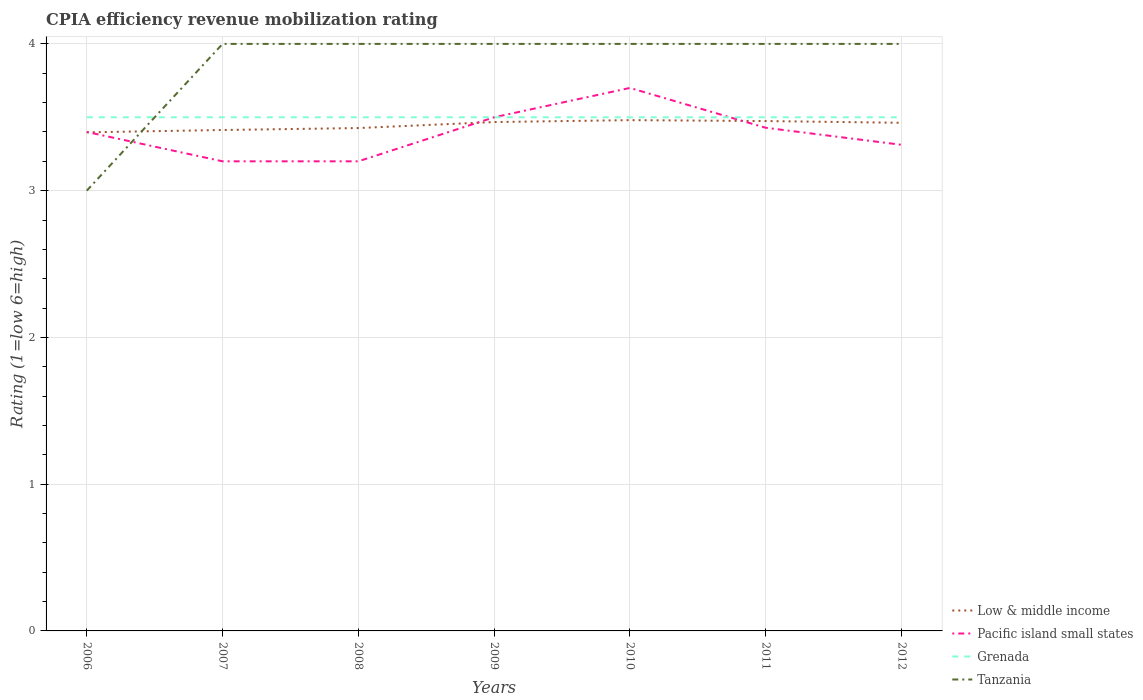Is the number of lines equal to the number of legend labels?
Offer a very short reply. Yes. Across all years, what is the maximum CPIA rating in Low & middle income?
Your response must be concise. 3.4. In which year was the CPIA rating in Tanzania maximum?
Your answer should be very brief. 2006. Is the CPIA rating in Grenada strictly greater than the CPIA rating in Tanzania over the years?
Give a very brief answer. No. How many lines are there?
Make the answer very short. 4. How many years are there in the graph?
Your answer should be very brief. 7. What is the difference between two consecutive major ticks on the Y-axis?
Your answer should be very brief. 1. Does the graph contain any zero values?
Give a very brief answer. No. How many legend labels are there?
Ensure brevity in your answer.  4. What is the title of the graph?
Make the answer very short. CPIA efficiency revenue mobilization rating. Does "Sierra Leone" appear as one of the legend labels in the graph?
Give a very brief answer. No. What is the Rating (1=low 6=high) in Low & middle income in 2006?
Keep it short and to the point. 3.4. What is the Rating (1=low 6=high) in Tanzania in 2006?
Your response must be concise. 3. What is the Rating (1=low 6=high) in Low & middle income in 2007?
Provide a short and direct response. 3.41. What is the Rating (1=low 6=high) of Grenada in 2007?
Offer a very short reply. 3.5. What is the Rating (1=low 6=high) of Low & middle income in 2008?
Your response must be concise. 3.43. What is the Rating (1=low 6=high) in Pacific island small states in 2008?
Provide a succinct answer. 3.2. What is the Rating (1=low 6=high) of Grenada in 2008?
Offer a terse response. 3.5. What is the Rating (1=low 6=high) in Low & middle income in 2009?
Provide a succinct answer. 3.47. What is the Rating (1=low 6=high) of Pacific island small states in 2009?
Make the answer very short. 3.5. What is the Rating (1=low 6=high) in Grenada in 2009?
Give a very brief answer. 3.5. What is the Rating (1=low 6=high) of Tanzania in 2009?
Your response must be concise. 4. What is the Rating (1=low 6=high) of Low & middle income in 2010?
Your response must be concise. 3.48. What is the Rating (1=low 6=high) of Tanzania in 2010?
Provide a succinct answer. 4. What is the Rating (1=low 6=high) of Low & middle income in 2011?
Your answer should be compact. 3.47. What is the Rating (1=low 6=high) in Pacific island small states in 2011?
Your answer should be very brief. 3.43. What is the Rating (1=low 6=high) in Low & middle income in 2012?
Your response must be concise. 3.46. What is the Rating (1=low 6=high) in Pacific island small states in 2012?
Make the answer very short. 3.31. What is the Rating (1=low 6=high) of Grenada in 2012?
Provide a short and direct response. 3.5. What is the Rating (1=low 6=high) of Tanzania in 2012?
Offer a very short reply. 4. Across all years, what is the maximum Rating (1=low 6=high) of Low & middle income?
Your answer should be compact. 3.48. Across all years, what is the maximum Rating (1=low 6=high) of Pacific island small states?
Your response must be concise. 3.7. Across all years, what is the maximum Rating (1=low 6=high) in Grenada?
Give a very brief answer. 3.5. Across all years, what is the minimum Rating (1=low 6=high) of Low & middle income?
Your answer should be very brief. 3.4. Across all years, what is the minimum Rating (1=low 6=high) of Grenada?
Provide a short and direct response. 3.5. What is the total Rating (1=low 6=high) in Low & middle income in the graph?
Your answer should be very brief. 24.12. What is the total Rating (1=low 6=high) of Pacific island small states in the graph?
Make the answer very short. 23.74. What is the total Rating (1=low 6=high) in Tanzania in the graph?
Keep it short and to the point. 27. What is the difference between the Rating (1=low 6=high) in Low & middle income in 2006 and that in 2007?
Ensure brevity in your answer.  -0.02. What is the difference between the Rating (1=low 6=high) of Pacific island small states in 2006 and that in 2007?
Give a very brief answer. 0.2. What is the difference between the Rating (1=low 6=high) of Grenada in 2006 and that in 2007?
Provide a succinct answer. 0. What is the difference between the Rating (1=low 6=high) in Tanzania in 2006 and that in 2007?
Offer a terse response. -1. What is the difference between the Rating (1=low 6=high) of Low & middle income in 2006 and that in 2008?
Give a very brief answer. -0.03. What is the difference between the Rating (1=low 6=high) of Pacific island small states in 2006 and that in 2008?
Make the answer very short. 0.2. What is the difference between the Rating (1=low 6=high) of Low & middle income in 2006 and that in 2009?
Offer a very short reply. -0.07. What is the difference between the Rating (1=low 6=high) of Pacific island small states in 2006 and that in 2009?
Your answer should be very brief. -0.1. What is the difference between the Rating (1=low 6=high) of Low & middle income in 2006 and that in 2010?
Your response must be concise. -0.08. What is the difference between the Rating (1=low 6=high) of Low & middle income in 2006 and that in 2011?
Provide a succinct answer. -0.08. What is the difference between the Rating (1=low 6=high) of Pacific island small states in 2006 and that in 2011?
Keep it short and to the point. -0.03. What is the difference between the Rating (1=low 6=high) of Tanzania in 2006 and that in 2011?
Give a very brief answer. -1. What is the difference between the Rating (1=low 6=high) of Low & middle income in 2006 and that in 2012?
Offer a very short reply. -0.07. What is the difference between the Rating (1=low 6=high) in Pacific island small states in 2006 and that in 2012?
Offer a terse response. 0.09. What is the difference between the Rating (1=low 6=high) of Low & middle income in 2007 and that in 2008?
Your answer should be very brief. -0.01. What is the difference between the Rating (1=low 6=high) in Pacific island small states in 2007 and that in 2008?
Your answer should be very brief. 0. What is the difference between the Rating (1=low 6=high) of Grenada in 2007 and that in 2008?
Your response must be concise. 0. What is the difference between the Rating (1=low 6=high) in Low & middle income in 2007 and that in 2009?
Provide a succinct answer. -0.05. What is the difference between the Rating (1=low 6=high) of Pacific island small states in 2007 and that in 2009?
Provide a short and direct response. -0.3. What is the difference between the Rating (1=low 6=high) in Grenada in 2007 and that in 2009?
Give a very brief answer. 0. What is the difference between the Rating (1=low 6=high) in Low & middle income in 2007 and that in 2010?
Keep it short and to the point. -0.07. What is the difference between the Rating (1=low 6=high) of Pacific island small states in 2007 and that in 2010?
Provide a short and direct response. -0.5. What is the difference between the Rating (1=low 6=high) in Grenada in 2007 and that in 2010?
Your answer should be compact. 0. What is the difference between the Rating (1=low 6=high) of Low & middle income in 2007 and that in 2011?
Make the answer very short. -0.06. What is the difference between the Rating (1=low 6=high) of Pacific island small states in 2007 and that in 2011?
Offer a very short reply. -0.23. What is the difference between the Rating (1=low 6=high) of Grenada in 2007 and that in 2011?
Give a very brief answer. 0. What is the difference between the Rating (1=low 6=high) of Tanzania in 2007 and that in 2011?
Make the answer very short. 0. What is the difference between the Rating (1=low 6=high) in Low & middle income in 2007 and that in 2012?
Provide a succinct answer. -0.05. What is the difference between the Rating (1=low 6=high) of Pacific island small states in 2007 and that in 2012?
Make the answer very short. -0.11. What is the difference between the Rating (1=low 6=high) in Tanzania in 2007 and that in 2012?
Offer a very short reply. 0. What is the difference between the Rating (1=low 6=high) in Low & middle income in 2008 and that in 2009?
Your response must be concise. -0.04. What is the difference between the Rating (1=low 6=high) of Pacific island small states in 2008 and that in 2009?
Make the answer very short. -0.3. What is the difference between the Rating (1=low 6=high) in Grenada in 2008 and that in 2009?
Provide a succinct answer. 0. What is the difference between the Rating (1=low 6=high) of Tanzania in 2008 and that in 2009?
Ensure brevity in your answer.  0. What is the difference between the Rating (1=low 6=high) of Low & middle income in 2008 and that in 2010?
Your answer should be compact. -0.05. What is the difference between the Rating (1=low 6=high) in Pacific island small states in 2008 and that in 2010?
Give a very brief answer. -0.5. What is the difference between the Rating (1=low 6=high) in Grenada in 2008 and that in 2010?
Make the answer very short. 0. What is the difference between the Rating (1=low 6=high) of Tanzania in 2008 and that in 2010?
Your answer should be compact. 0. What is the difference between the Rating (1=low 6=high) in Low & middle income in 2008 and that in 2011?
Your response must be concise. -0.05. What is the difference between the Rating (1=low 6=high) of Pacific island small states in 2008 and that in 2011?
Provide a short and direct response. -0.23. What is the difference between the Rating (1=low 6=high) of Grenada in 2008 and that in 2011?
Make the answer very short. 0. What is the difference between the Rating (1=low 6=high) of Low & middle income in 2008 and that in 2012?
Keep it short and to the point. -0.04. What is the difference between the Rating (1=low 6=high) of Pacific island small states in 2008 and that in 2012?
Ensure brevity in your answer.  -0.11. What is the difference between the Rating (1=low 6=high) of Low & middle income in 2009 and that in 2010?
Ensure brevity in your answer.  -0.01. What is the difference between the Rating (1=low 6=high) in Grenada in 2009 and that in 2010?
Ensure brevity in your answer.  0. What is the difference between the Rating (1=low 6=high) in Low & middle income in 2009 and that in 2011?
Keep it short and to the point. -0.01. What is the difference between the Rating (1=low 6=high) in Pacific island small states in 2009 and that in 2011?
Ensure brevity in your answer.  0.07. What is the difference between the Rating (1=low 6=high) in Grenada in 2009 and that in 2011?
Your answer should be very brief. 0. What is the difference between the Rating (1=low 6=high) of Tanzania in 2009 and that in 2011?
Provide a short and direct response. 0. What is the difference between the Rating (1=low 6=high) of Low & middle income in 2009 and that in 2012?
Ensure brevity in your answer.  0.01. What is the difference between the Rating (1=low 6=high) of Pacific island small states in 2009 and that in 2012?
Ensure brevity in your answer.  0.19. What is the difference between the Rating (1=low 6=high) of Low & middle income in 2010 and that in 2011?
Your response must be concise. 0.01. What is the difference between the Rating (1=low 6=high) of Pacific island small states in 2010 and that in 2011?
Keep it short and to the point. 0.27. What is the difference between the Rating (1=low 6=high) in Tanzania in 2010 and that in 2011?
Keep it short and to the point. 0. What is the difference between the Rating (1=low 6=high) in Low & middle income in 2010 and that in 2012?
Offer a very short reply. 0.02. What is the difference between the Rating (1=low 6=high) in Pacific island small states in 2010 and that in 2012?
Give a very brief answer. 0.39. What is the difference between the Rating (1=low 6=high) in Grenada in 2010 and that in 2012?
Provide a short and direct response. 0. What is the difference between the Rating (1=low 6=high) in Tanzania in 2010 and that in 2012?
Offer a very short reply. 0. What is the difference between the Rating (1=low 6=high) of Low & middle income in 2011 and that in 2012?
Provide a short and direct response. 0.01. What is the difference between the Rating (1=low 6=high) of Pacific island small states in 2011 and that in 2012?
Your answer should be very brief. 0.12. What is the difference between the Rating (1=low 6=high) of Tanzania in 2011 and that in 2012?
Provide a succinct answer. 0. What is the difference between the Rating (1=low 6=high) in Low & middle income in 2006 and the Rating (1=low 6=high) in Pacific island small states in 2007?
Offer a very short reply. 0.2. What is the difference between the Rating (1=low 6=high) of Low & middle income in 2006 and the Rating (1=low 6=high) of Grenada in 2007?
Your answer should be compact. -0.1. What is the difference between the Rating (1=low 6=high) of Low & middle income in 2006 and the Rating (1=low 6=high) of Tanzania in 2007?
Ensure brevity in your answer.  -0.6. What is the difference between the Rating (1=low 6=high) in Pacific island small states in 2006 and the Rating (1=low 6=high) in Tanzania in 2007?
Provide a succinct answer. -0.6. What is the difference between the Rating (1=low 6=high) in Low & middle income in 2006 and the Rating (1=low 6=high) in Pacific island small states in 2008?
Keep it short and to the point. 0.2. What is the difference between the Rating (1=low 6=high) of Low & middle income in 2006 and the Rating (1=low 6=high) of Grenada in 2008?
Offer a terse response. -0.1. What is the difference between the Rating (1=low 6=high) of Low & middle income in 2006 and the Rating (1=low 6=high) of Tanzania in 2008?
Provide a short and direct response. -0.6. What is the difference between the Rating (1=low 6=high) of Pacific island small states in 2006 and the Rating (1=low 6=high) of Grenada in 2008?
Keep it short and to the point. -0.1. What is the difference between the Rating (1=low 6=high) in Grenada in 2006 and the Rating (1=low 6=high) in Tanzania in 2008?
Your response must be concise. -0.5. What is the difference between the Rating (1=low 6=high) in Low & middle income in 2006 and the Rating (1=low 6=high) in Pacific island small states in 2009?
Provide a short and direct response. -0.1. What is the difference between the Rating (1=low 6=high) of Low & middle income in 2006 and the Rating (1=low 6=high) of Grenada in 2009?
Your answer should be very brief. -0.1. What is the difference between the Rating (1=low 6=high) of Low & middle income in 2006 and the Rating (1=low 6=high) of Tanzania in 2009?
Keep it short and to the point. -0.6. What is the difference between the Rating (1=low 6=high) of Pacific island small states in 2006 and the Rating (1=low 6=high) of Grenada in 2009?
Your answer should be very brief. -0.1. What is the difference between the Rating (1=low 6=high) of Low & middle income in 2006 and the Rating (1=low 6=high) of Pacific island small states in 2010?
Your response must be concise. -0.3. What is the difference between the Rating (1=low 6=high) in Low & middle income in 2006 and the Rating (1=low 6=high) in Grenada in 2010?
Your answer should be very brief. -0.1. What is the difference between the Rating (1=low 6=high) of Low & middle income in 2006 and the Rating (1=low 6=high) of Tanzania in 2010?
Provide a short and direct response. -0.6. What is the difference between the Rating (1=low 6=high) in Grenada in 2006 and the Rating (1=low 6=high) in Tanzania in 2010?
Offer a very short reply. -0.5. What is the difference between the Rating (1=low 6=high) of Low & middle income in 2006 and the Rating (1=low 6=high) of Pacific island small states in 2011?
Provide a succinct answer. -0.03. What is the difference between the Rating (1=low 6=high) of Low & middle income in 2006 and the Rating (1=low 6=high) of Grenada in 2011?
Provide a short and direct response. -0.1. What is the difference between the Rating (1=low 6=high) in Low & middle income in 2006 and the Rating (1=low 6=high) in Tanzania in 2011?
Provide a succinct answer. -0.6. What is the difference between the Rating (1=low 6=high) of Pacific island small states in 2006 and the Rating (1=low 6=high) of Tanzania in 2011?
Your answer should be compact. -0.6. What is the difference between the Rating (1=low 6=high) in Grenada in 2006 and the Rating (1=low 6=high) in Tanzania in 2011?
Your answer should be very brief. -0.5. What is the difference between the Rating (1=low 6=high) in Low & middle income in 2006 and the Rating (1=low 6=high) in Pacific island small states in 2012?
Give a very brief answer. 0.08. What is the difference between the Rating (1=low 6=high) in Low & middle income in 2006 and the Rating (1=low 6=high) in Grenada in 2012?
Ensure brevity in your answer.  -0.1. What is the difference between the Rating (1=low 6=high) in Low & middle income in 2006 and the Rating (1=low 6=high) in Tanzania in 2012?
Provide a short and direct response. -0.6. What is the difference between the Rating (1=low 6=high) of Pacific island small states in 2006 and the Rating (1=low 6=high) of Tanzania in 2012?
Offer a very short reply. -0.6. What is the difference between the Rating (1=low 6=high) in Grenada in 2006 and the Rating (1=low 6=high) in Tanzania in 2012?
Keep it short and to the point. -0.5. What is the difference between the Rating (1=low 6=high) of Low & middle income in 2007 and the Rating (1=low 6=high) of Pacific island small states in 2008?
Offer a terse response. 0.21. What is the difference between the Rating (1=low 6=high) in Low & middle income in 2007 and the Rating (1=low 6=high) in Grenada in 2008?
Provide a succinct answer. -0.09. What is the difference between the Rating (1=low 6=high) of Low & middle income in 2007 and the Rating (1=low 6=high) of Tanzania in 2008?
Offer a terse response. -0.59. What is the difference between the Rating (1=low 6=high) of Grenada in 2007 and the Rating (1=low 6=high) of Tanzania in 2008?
Your response must be concise. -0.5. What is the difference between the Rating (1=low 6=high) in Low & middle income in 2007 and the Rating (1=low 6=high) in Pacific island small states in 2009?
Provide a short and direct response. -0.09. What is the difference between the Rating (1=low 6=high) in Low & middle income in 2007 and the Rating (1=low 6=high) in Grenada in 2009?
Provide a short and direct response. -0.09. What is the difference between the Rating (1=low 6=high) in Low & middle income in 2007 and the Rating (1=low 6=high) in Tanzania in 2009?
Give a very brief answer. -0.59. What is the difference between the Rating (1=low 6=high) of Pacific island small states in 2007 and the Rating (1=low 6=high) of Tanzania in 2009?
Ensure brevity in your answer.  -0.8. What is the difference between the Rating (1=low 6=high) of Low & middle income in 2007 and the Rating (1=low 6=high) of Pacific island small states in 2010?
Make the answer very short. -0.29. What is the difference between the Rating (1=low 6=high) in Low & middle income in 2007 and the Rating (1=low 6=high) in Grenada in 2010?
Offer a very short reply. -0.09. What is the difference between the Rating (1=low 6=high) of Low & middle income in 2007 and the Rating (1=low 6=high) of Tanzania in 2010?
Give a very brief answer. -0.59. What is the difference between the Rating (1=low 6=high) of Pacific island small states in 2007 and the Rating (1=low 6=high) of Tanzania in 2010?
Make the answer very short. -0.8. What is the difference between the Rating (1=low 6=high) of Grenada in 2007 and the Rating (1=low 6=high) of Tanzania in 2010?
Your answer should be compact. -0.5. What is the difference between the Rating (1=low 6=high) in Low & middle income in 2007 and the Rating (1=low 6=high) in Pacific island small states in 2011?
Your answer should be very brief. -0.02. What is the difference between the Rating (1=low 6=high) in Low & middle income in 2007 and the Rating (1=low 6=high) in Grenada in 2011?
Offer a terse response. -0.09. What is the difference between the Rating (1=low 6=high) of Low & middle income in 2007 and the Rating (1=low 6=high) of Tanzania in 2011?
Keep it short and to the point. -0.59. What is the difference between the Rating (1=low 6=high) of Grenada in 2007 and the Rating (1=low 6=high) of Tanzania in 2011?
Your answer should be compact. -0.5. What is the difference between the Rating (1=low 6=high) in Low & middle income in 2007 and the Rating (1=low 6=high) in Pacific island small states in 2012?
Your response must be concise. 0.1. What is the difference between the Rating (1=low 6=high) in Low & middle income in 2007 and the Rating (1=low 6=high) in Grenada in 2012?
Ensure brevity in your answer.  -0.09. What is the difference between the Rating (1=low 6=high) in Low & middle income in 2007 and the Rating (1=low 6=high) in Tanzania in 2012?
Your response must be concise. -0.59. What is the difference between the Rating (1=low 6=high) in Grenada in 2007 and the Rating (1=low 6=high) in Tanzania in 2012?
Give a very brief answer. -0.5. What is the difference between the Rating (1=low 6=high) of Low & middle income in 2008 and the Rating (1=low 6=high) of Pacific island small states in 2009?
Keep it short and to the point. -0.07. What is the difference between the Rating (1=low 6=high) of Low & middle income in 2008 and the Rating (1=low 6=high) of Grenada in 2009?
Make the answer very short. -0.07. What is the difference between the Rating (1=low 6=high) in Low & middle income in 2008 and the Rating (1=low 6=high) in Tanzania in 2009?
Provide a short and direct response. -0.57. What is the difference between the Rating (1=low 6=high) in Grenada in 2008 and the Rating (1=low 6=high) in Tanzania in 2009?
Keep it short and to the point. -0.5. What is the difference between the Rating (1=low 6=high) of Low & middle income in 2008 and the Rating (1=low 6=high) of Pacific island small states in 2010?
Provide a succinct answer. -0.27. What is the difference between the Rating (1=low 6=high) in Low & middle income in 2008 and the Rating (1=low 6=high) in Grenada in 2010?
Your answer should be very brief. -0.07. What is the difference between the Rating (1=low 6=high) of Low & middle income in 2008 and the Rating (1=low 6=high) of Tanzania in 2010?
Provide a succinct answer. -0.57. What is the difference between the Rating (1=low 6=high) in Pacific island small states in 2008 and the Rating (1=low 6=high) in Grenada in 2010?
Provide a succinct answer. -0.3. What is the difference between the Rating (1=low 6=high) of Pacific island small states in 2008 and the Rating (1=low 6=high) of Tanzania in 2010?
Your answer should be compact. -0.8. What is the difference between the Rating (1=low 6=high) in Grenada in 2008 and the Rating (1=low 6=high) in Tanzania in 2010?
Your answer should be very brief. -0.5. What is the difference between the Rating (1=low 6=high) of Low & middle income in 2008 and the Rating (1=low 6=high) of Pacific island small states in 2011?
Provide a succinct answer. -0. What is the difference between the Rating (1=low 6=high) of Low & middle income in 2008 and the Rating (1=low 6=high) of Grenada in 2011?
Make the answer very short. -0.07. What is the difference between the Rating (1=low 6=high) of Low & middle income in 2008 and the Rating (1=low 6=high) of Tanzania in 2011?
Keep it short and to the point. -0.57. What is the difference between the Rating (1=low 6=high) in Pacific island small states in 2008 and the Rating (1=low 6=high) in Tanzania in 2011?
Provide a short and direct response. -0.8. What is the difference between the Rating (1=low 6=high) of Grenada in 2008 and the Rating (1=low 6=high) of Tanzania in 2011?
Provide a short and direct response. -0.5. What is the difference between the Rating (1=low 6=high) in Low & middle income in 2008 and the Rating (1=low 6=high) in Pacific island small states in 2012?
Provide a short and direct response. 0.11. What is the difference between the Rating (1=low 6=high) of Low & middle income in 2008 and the Rating (1=low 6=high) of Grenada in 2012?
Provide a succinct answer. -0.07. What is the difference between the Rating (1=low 6=high) of Low & middle income in 2008 and the Rating (1=low 6=high) of Tanzania in 2012?
Make the answer very short. -0.57. What is the difference between the Rating (1=low 6=high) of Grenada in 2008 and the Rating (1=low 6=high) of Tanzania in 2012?
Your answer should be very brief. -0.5. What is the difference between the Rating (1=low 6=high) of Low & middle income in 2009 and the Rating (1=low 6=high) of Pacific island small states in 2010?
Offer a terse response. -0.23. What is the difference between the Rating (1=low 6=high) of Low & middle income in 2009 and the Rating (1=low 6=high) of Grenada in 2010?
Offer a terse response. -0.03. What is the difference between the Rating (1=low 6=high) of Low & middle income in 2009 and the Rating (1=low 6=high) of Tanzania in 2010?
Ensure brevity in your answer.  -0.53. What is the difference between the Rating (1=low 6=high) in Pacific island small states in 2009 and the Rating (1=low 6=high) in Grenada in 2010?
Make the answer very short. 0. What is the difference between the Rating (1=low 6=high) of Low & middle income in 2009 and the Rating (1=low 6=high) of Pacific island small states in 2011?
Ensure brevity in your answer.  0.04. What is the difference between the Rating (1=low 6=high) of Low & middle income in 2009 and the Rating (1=low 6=high) of Grenada in 2011?
Give a very brief answer. -0.03. What is the difference between the Rating (1=low 6=high) in Low & middle income in 2009 and the Rating (1=low 6=high) in Tanzania in 2011?
Provide a short and direct response. -0.53. What is the difference between the Rating (1=low 6=high) in Pacific island small states in 2009 and the Rating (1=low 6=high) in Tanzania in 2011?
Your answer should be very brief. -0.5. What is the difference between the Rating (1=low 6=high) of Low & middle income in 2009 and the Rating (1=low 6=high) of Pacific island small states in 2012?
Offer a terse response. 0.15. What is the difference between the Rating (1=low 6=high) of Low & middle income in 2009 and the Rating (1=low 6=high) of Grenada in 2012?
Offer a terse response. -0.03. What is the difference between the Rating (1=low 6=high) in Low & middle income in 2009 and the Rating (1=low 6=high) in Tanzania in 2012?
Your answer should be compact. -0.53. What is the difference between the Rating (1=low 6=high) of Pacific island small states in 2009 and the Rating (1=low 6=high) of Tanzania in 2012?
Provide a succinct answer. -0.5. What is the difference between the Rating (1=low 6=high) in Grenada in 2009 and the Rating (1=low 6=high) in Tanzania in 2012?
Provide a short and direct response. -0.5. What is the difference between the Rating (1=low 6=high) in Low & middle income in 2010 and the Rating (1=low 6=high) in Pacific island small states in 2011?
Your answer should be compact. 0.05. What is the difference between the Rating (1=low 6=high) in Low & middle income in 2010 and the Rating (1=low 6=high) in Grenada in 2011?
Provide a succinct answer. -0.02. What is the difference between the Rating (1=low 6=high) in Low & middle income in 2010 and the Rating (1=low 6=high) in Tanzania in 2011?
Ensure brevity in your answer.  -0.52. What is the difference between the Rating (1=low 6=high) in Pacific island small states in 2010 and the Rating (1=low 6=high) in Grenada in 2011?
Offer a terse response. 0.2. What is the difference between the Rating (1=low 6=high) of Pacific island small states in 2010 and the Rating (1=low 6=high) of Tanzania in 2011?
Make the answer very short. -0.3. What is the difference between the Rating (1=low 6=high) of Grenada in 2010 and the Rating (1=low 6=high) of Tanzania in 2011?
Offer a very short reply. -0.5. What is the difference between the Rating (1=low 6=high) in Low & middle income in 2010 and the Rating (1=low 6=high) in Pacific island small states in 2012?
Give a very brief answer. 0.17. What is the difference between the Rating (1=low 6=high) of Low & middle income in 2010 and the Rating (1=low 6=high) of Grenada in 2012?
Keep it short and to the point. -0.02. What is the difference between the Rating (1=low 6=high) of Low & middle income in 2010 and the Rating (1=low 6=high) of Tanzania in 2012?
Make the answer very short. -0.52. What is the difference between the Rating (1=low 6=high) of Pacific island small states in 2010 and the Rating (1=low 6=high) of Grenada in 2012?
Your answer should be very brief. 0.2. What is the difference between the Rating (1=low 6=high) in Pacific island small states in 2010 and the Rating (1=low 6=high) in Tanzania in 2012?
Offer a very short reply. -0.3. What is the difference between the Rating (1=low 6=high) of Grenada in 2010 and the Rating (1=low 6=high) of Tanzania in 2012?
Your answer should be very brief. -0.5. What is the difference between the Rating (1=low 6=high) in Low & middle income in 2011 and the Rating (1=low 6=high) in Pacific island small states in 2012?
Give a very brief answer. 0.16. What is the difference between the Rating (1=low 6=high) of Low & middle income in 2011 and the Rating (1=low 6=high) of Grenada in 2012?
Provide a short and direct response. -0.03. What is the difference between the Rating (1=low 6=high) in Low & middle income in 2011 and the Rating (1=low 6=high) in Tanzania in 2012?
Your answer should be compact. -0.53. What is the difference between the Rating (1=low 6=high) in Pacific island small states in 2011 and the Rating (1=low 6=high) in Grenada in 2012?
Provide a short and direct response. -0.07. What is the difference between the Rating (1=low 6=high) of Pacific island small states in 2011 and the Rating (1=low 6=high) of Tanzania in 2012?
Ensure brevity in your answer.  -0.57. What is the difference between the Rating (1=low 6=high) of Grenada in 2011 and the Rating (1=low 6=high) of Tanzania in 2012?
Keep it short and to the point. -0.5. What is the average Rating (1=low 6=high) in Low & middle income per year?
Give a very brief answer. 3.45. What is the average Rating (1=low 6=high) of Pacific island small states per year?
Your answer should be compact. 3.39. What is the average Rating (1=low 6=high) in Tanzania per year?
Your response must be concise. 3.86. In the year 2006, what is the difference between the Rating (1=low 6=high) in Low & middle income and Rating (1=low 6=high) in Pacific island small states?
Provide a succinct answer. -0. In the year 2006, what is the difference between the Rating (1=low 6=high) in Low & middle income and Rating (1=low 6=high) in Grenada?
Offer a very short reply. -0.1. In the year 2006, what is the difference between the Rating (1=low 6=high) in Low & middle income and Rating (1=low 6=high) in Tanzania?
Provide a short and direct response. 0.4. In the year 2006, what is the difference between the Rating (1=low 6=high) of Pacific island small states and Rating (1=low 6=high) of Grenada?
Offer a very short reply. -0.1. In the year 2006, what is the difference between the Rating (1=low 6=high) of Pacific island small states and Rating (1=low 6=high) of Tanzania?
Make the answer very short. 0.4. In the year 2006, what is the difference between the Rating (1=low 6=high) of Grenada and Rating (1=low 6=high) of Tanzania?
Offer a terse response. 0.5. In the year 2007, what is the difference between the Rating (1=low 6=high) in Low & middle income and Rating (1=low 6=high) in Pacific island small states?
Your answer should be compact. 0.21. In the year 2007, what is the difference between the Rating (1=low 6=high) of Low & middle income and Rating (1=low 6=high) of Grenada?
Offer a terse response. -0.09. In the year 2007, what is the difference between the Rating (1=low 6=high) in Low & middle income and Rating (1=low 6=high) in Tanzania?
Keep it short and to the point. -0.59. In the year 2007, what is the difference between the Rating (1=low 6=high) in Pacific island small states and Rating (1=low 6=high) in Grenada?
Your answer should be compact. -0.3. In the year 2007, what is the difference between the Rating (1=low 6=high) in Grenada and Rating (1=low 6=high) in Tanzania?
Your answer should be very brief. -0.5. In the year 2008, what is the difference between the Rating (1=low 6=high) of Low & middle income and Rating (1=low 6=high) of Pacific island small states?
Make the answer very short. 0.23. In the year 2008, what is the difference between the Rating (1=low 6=high) in Low & middle income and Rating (1=low 6=high) in Grenada?
Your answer should be very brief. -0.07. In the year 2008, what is the difference between the Rating (1=low 6=high) in Low & middle income and Rating (1=low 6=high) in Tanzania?
Give a very brief answer. -0.57. In the year 2008, what is the difference between the Rating (1=low 6=high) in Pacific island small states and Rating (1=low 6=high) in Grenada?
Give a very brief answer. -0.3. In the year 2009, what is the difference between the Rating (1=low 6=high) in Low & middle income and Rating (1=low 6=high) in Pacific island small states?
Make the answer very short. -0.03. In the year 2009, what is the difference between the Rating (1=low 6=high) of Low & middle income and Rating (1=low 6=high) of Grenada?
Offer a terse response. -0.03. In the year 2009, what is the difference between the Rating (1=low 6=high) in Low & middle income and Rating (1=low 6=high) in Tanzania?
Provide a succinct answer. -0.53. In the year 2009, what is the difference between the Rating (1=low 6=high) of Pacific island small states and Rating (1=low 6=high) of Grenada?
Your response must be concise. 0. In the year 2009, what is the difference between the Rating (1=low 6=high) of Pacific island small states and Rating (1=low 6=high) of Tanzania?
Provide a succinct answer. -0.5. In the year 2009, what is the difference between the Rating (1=low 6=high) of Grenada and Rating (1=low 6=high) of Tanzania?
Provide a succinct answer. -0.5. In the year 2010, what is the difference between the Rating (1=low 6=high) in Low & middle income and Rating (1=low 6=high) in Pacific island small states?
Keep it short and to the point. -0.22. In the year 2010, what is the difference between the Rating (1=low 6=high) of Low & middle income and Rating (1=low 6=high) of Grenada?
Your response must be concise. -0.02. In the year 2010, what is the difference between the Rating (1=low 6=high) of Low & middle income and Rating (1=low 6=high) of Tanzania?
Your answer should be very brief. -0.52. In the year 2010, what is the difference between the Rating (1=low 6=high) of Pacific island small states and Rating (1=low 6=high) of Grenada?
Provide a succinct answer. 0.2. In the year 2010, what is the difference between the Rating (1=low 6=high) in Grenada and Rating (1=low 6=high) in Tanzania?
Provide a short and direct response. -0.5. In the year 2011, what is the difference between the Rating (1=low 6=high) of Low & middle income and Rating (1=low 6=high) of Pacific island small states?
Make the answer very short. 0.05. In the year 2011, what is the difference between the Rating (1=low 6=high) in Low & middle income and Rating (1=low 6=high) in Grenada?
Ensure brevity in your answer.  -0.03. In the year 2011, what is the difference between the Rating (1=low 6=high) in Low & middle income and Rating (1=low 6=high) in Tanzania?
Keep it short and to the point. -0.53. In the year 2011, what is the difference between the Rating (1=low 6=high) of Pacific island small states and Rating (1=low 6=high) of Grenada?
Offer a very short reply. -0.07. In the year 2011, what is the difference between the Rating (1=low 6=high) in Pacific island small states and Rating (1=low 6=high) in Tanzania?
Provide a succinct answer. -0.57. In the year 2011, what is the difference between the Rating (1=low 6=high) in Grenada and Rating (1=low 6=high) in Tanzania?
Ensure brevity in your answer.  -0.5. In the year 2012, what is the difference between the Rating (1=low 6=high) in Low & middle income and Rating (1=low 6=high) in Grenada?
Provide a succinct answer. -0.04. In the year 2012, what is the difference between the Rating (1=low 6=high) in Low & middle income and Rating (1=low 6=high) in Tanzania?
Ensure brevity in your answer.  -0.54. In the year 2012, what is the difference between the Rating (1=low 6=high) of Pacific island small states and Rating (1=low 6=high) of Grenada?
Ensure brevity in your answer.  -0.19. In the year 2012, what is the difference between the Rating (1=low 6=high) of Pacific island small states and Rating (1=low 6=high) of Tanzania?
Your answer should be very brief. -0.69. What is the ratio of the Rating (1=low 6=high) of Grenada in 2006 to that in 2007?
Offer a terse response. 1. What is the ratio of the Rating (1=low 6=high) of Low & middle income in 2006 to that in 2008?
Make the answer very short. 0.99. What is the ratio of the Rating (1=low 6=high) of Low & middle income in 2006 to that in 2009?
Offer a terse response. 0.98. What is the ratio of the Rating (1=low 6=high) in Pacific island small states in 2006 to that in 2009?
Your answer should be compact. 0.97. What is the ratio of the Rating (1=low 6=high) in Grenada in 2006 to that in 2009?
Make the answer very short. 1. What is the ratio of the Rating (1=low 6=high) of Tanzania in 2006 to that in 2009?
Provide a succinct answer. 0.75. What is the ratio of the Rating (1=low 6=high) of Low & middle income in 2006 to that in 2010?
Your answer should be very brief. 0.98. What is the ratio of the Rating (1=low 6=high) in Pacific island small states in 2006 to that in 2010?
Ensure brevity in your answer.  0.92. What is the ratio of the Rating (1=low 6=high) in Low & middle income in 2006 to that in 2011?
Give a very brief answer. 0.98. What is the ratio of the Rating (1=low 6=high) in Pacific island small states in 2006 to that in 2011?
Provide a short and direct response. 0.99. What is the ratio of the Rating (1=low 6=high) in Tanzania in 2006 to that in 2011?
Provide a short and direct response. 0.75. What is the ratio of the Rating (1=low 6=high) in Low & middle income in 2006 to that in 2012?
Your answer should be compact. 0.98. What is the ratio of the Rating (1=low 6=high) of Pacific island small states in 2006 to that in 2012?
Offer a terse response. 1.03. What is the ratio of the Rating (1=low 6=high) in Grenada in 2006 to that in 2012?
Your answer should be very brief. 1. What is the ratio of the Rating (1=low 6=high) in Grenada in 2007 to that in 2008?
Your response must be concise. 1. What is the ratio of the Rating (1=low 6=high) in Tanzania in 2007 to that in 2008?
Give a very brief answer. 1. What is the ratio of the Rating (1=low 6=high) of Low & middle income in 2007 to that in 2009?
Provide a short and direct response. 0.98. What is the ratio of the Rating (1=low 6=high) in Pacific island small states in 2007 to that in 2009?
Ensure brevity in your answer.  0.91. What is the ratio of the Rating (1=low 6=high) in Low & middle income in 2007 to that in 2010?
Offer a very short reply. 0.98. What is the ratio of the Rating (1=low 6=high) of Pacific island small states in 2007 to that in 2010?
Provide a short and direct response. 0.86. What is the ratio of the Rating (1=low 6=high) of Tanzania in 2007 to that in 2010?
Your response must be concise. 1. What is the ratio of the Rating (1=low 6=high) in Low & middle income in 2007 to that in 2011?
Keep it short and to the point. 0.98. What is the ratio of the Rating (1=low 6=high) in Pacific island small states in 2007 to that in 2011?
Offer a very short reply. 0.93. What is the ratio of the Rating (1=low 6=high) in Grenada in 2007 to that in 2011?
Keep it short and to the point. 1. What is the ratio of the Rating (1=low 6=high) of Tanzania in 2007 to that in 2011?
Provide a short and direct response. 1. What is the ratio of the Rating (1=low 6=high) in Low & middle income in 2007 to that in 2012?
Offer a terse response. 0.99. What is the ratio of the Rating (1=low 6=high) of Pacific island small states in 2007 to that in 2012?
Make the answer very short. 0.97. What is the ratio of the Rating (1=low 6=high) of Grenada in 2007 to that in 2012?
Offer a terse response. 1. What is the ratio of the Rating (1=low 6=high) in Tanzania in 2007 to that in 2012?
Give a very brief answer. 1. What is the ratio of the Rating (1=low 6=high) in Pacific island small states in 2008 to that in 2009?
Ensure brevity in your answer.  0.91. What is the ratio of the Rating (1=low 6=high) of Low & middle income in 2008 to that in 2010?
Your answer should be compact. 0.98. What is the ratio of the Rating (1=low 6=high) of Pacific island small states in 2008 to that in 2010?
Ensure brevity in your answer.  0.86. What is the ratio of the Rating (1=low 6=high) in Grenada in 2008 to that in 2010?
Ensure brevity in your answer.  1. What is the ratio of the Rating (1=low 6=high) of Low & middle income in 2008 to that in 2011?
Provide a short and direct response. 0.99. What is the ratio of the Rating (1=low 6=high) in Grenada in 2008 to that in 2011?
Offer a terse response. 1. What is the ratio of the Rating (1=low 6=high) in Tanzania in 2008 to that in 2011?
Provide a succinct answer. 1. What is the ratio of the Rating (1=low 6=high) of Pacific island small states in 2008 to that in 2012?
Make the answer very short. 0.97. What is the ratio of the Rating (1=low 6=high) of Grenada in 2008 to that in 2012?
Keep it short and to the point. 1. What is the ratio of the Rating (1=low 6=high) of Low & middle income in 2009 to that in 2010?
Offer a very short reply. 1. What is the ratio of the Rating (1=low 6=high) in Pacific island small states in 2009 to that in 2010?
Ensure brevity in your answer.  0.95. What is the ratio of the Rating (1=low 6=high) in Pacific island small states in 2009 to that in 2011?
Give a very brief answer. 1.02. What is the ratio of the Rating (1=low 6=high) in Grenada in 2009 to that in 2011?
Provide a short and direct response. 1. What is the ratio of the Rating (1=low 6=high) in Tanzania in 2009 to that in 2011?
Provide a succinct answer. 1. What is the ratio of the Rating (1=low 6=high) in Low & middle income in 2009 to that in 2012?
Keep it short and to the point. 1. What is the ratio of the Rating (1=low 6=high) of Pacific island small states in 2009 to that in 2012?
Keep it short and to the point. 1.06. What is the ratio of the Rating (1=low 6=high) of Grenada in 2009 to that in 2012?
Offer a very short reply. 1. What is the ratio of the Rating (1=low 6=high) in Tanzania in 2009 to that in 2012?
Your answer should be very brief. 1. What is the ratio of the Rating (1=low 6=high) of Pacific island small states in 2010 to that in 2011?
Make the answer very short. 1.08. What is the ratio of the Rating (1=low 6=high) in Low & middle income in 2010 to that in 2012?
Ensure brevity in your answer.  1.01. What is the ratio of the Rating (1=low 6=high) in Pacific island small states in 2010 to that in 2012?
Offer a terse response. 1.12. What is the ratio of the Rating (1=low 6=high) of Grenada in 2010 to that in 2012?
Offer a terse response. 1. What is the ratio of the Rating (1=low 6=high) of Low & middle income in 2011 to that in 2012?
Provide a succinct answer. 1. What is the ratio of the Rating (1=low 6=high) in Pacific island small states in 2011 to that in 2012?
Ensure brevity in your answer.  1.03. What is the ratio of the Rating (1=low 6=high) of Tanzania in 2011 to that in 2012?
Keep it short and to the point. 1. What is the difference between the highest and the second highest Rating (1=low 6=high) of Low & middle income?
Offer a terse response. 0.01. What is the difference between the highest and the second highest Rating (1=low 6=high) in Grenada?
Ensure brevity in your answer.  0. What is the difference between the highest and the lowest Rating (1=low 6=high) of Low & middle income?
Your answer should be compact. 0.08. 